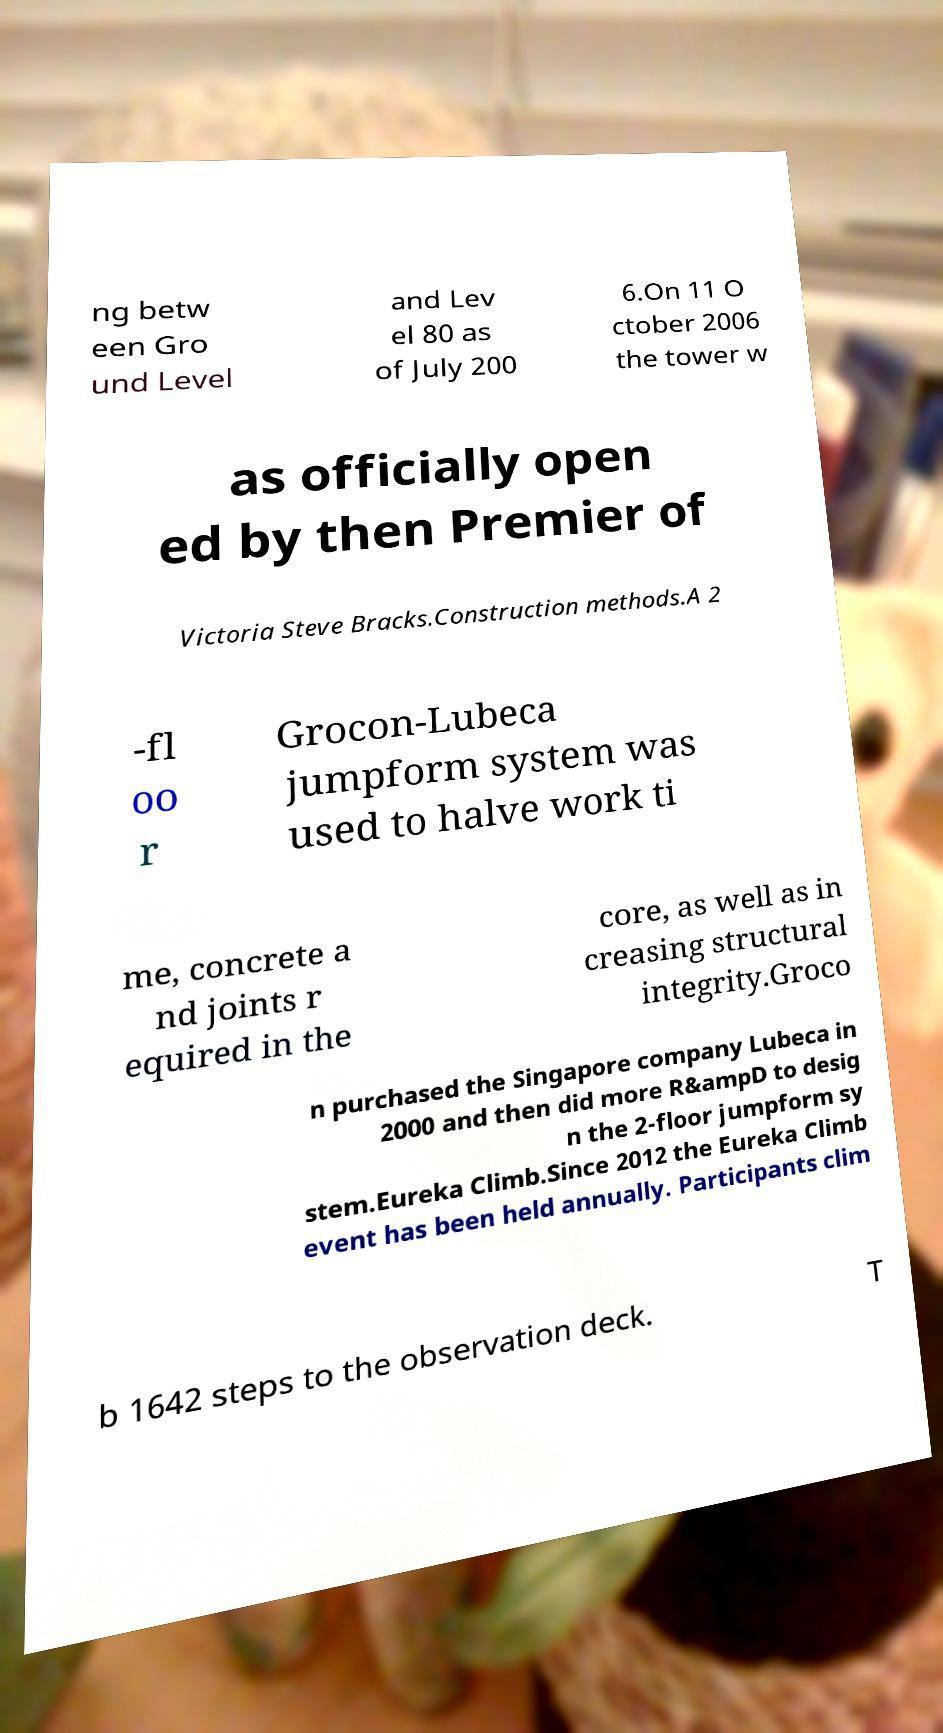Could you assist in decoding the text presented in this image and type it out clearly? ng betw een Gro und Level and Lev el 80 as of July 200 6.On 11 O ctober 2006 the tower w as officially open ed by then Premier of Victoria Steve Bracks.Construction methods.A 2 -fl oo r Grocon-Lubeca jumpform system was used to halve work ti me, concrete a nd joints r equired in the core, as well as in creasing structural integrity.Groco n purchased the Singapore company Lubeca in 2000 and then did more R&ampD to desig n the 2-floor jumpform sy stem.Eureka Climb.Since 2012 the Eureka Climb event has been held annually. Participants clim b 1642 steps to the observation deck. T 